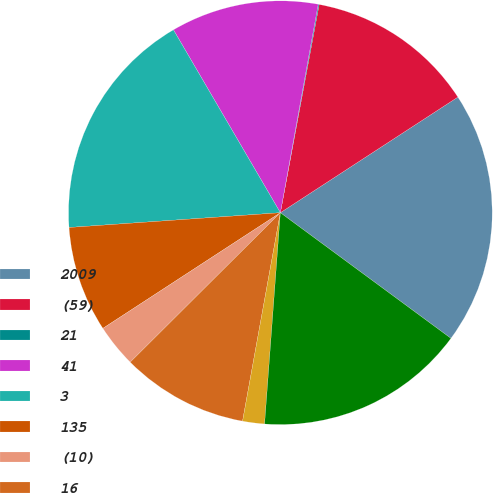<chart> <loc_0><loc_0><loc_500><loc_500><pie_chart><fcel>2009<fcel>(59)<fcel>21<fcel>41<fcel>3<fcel>135<fcel>(10)<fcel>16<fcel>(14)<fcel>130<nl><fcel>19.29%<fcel>12.88%<fcel>0.07%<fcel>11.28%<fcel>17.69%<fcel>8.08%<fcel>3.27%<fcel>9.68%<fcel>1.67%<fcel>16.08%<nl></chart> 